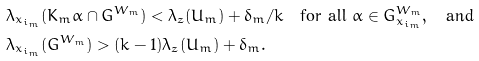<formula> <loc_0><loc_0><loc_500><loc_500>& \lambda _ { x _ { i _ { m } } } ( K _ { m } \alpha \cap G ^ { W _ { m } } ) < \lambda _ { z } ( U _ { m } ) + \delta _ { m } / k \quad \text {for all } \alpha \in G _ { x _ { i _ { m } } } ^ { W _ { m } } , \quad \text {and} \\ & \lambda _ { x _ { i _ { m } } } ( G ^ { W _ { m } } ) > ( k - 1 ) \lambda _ { z } ( U _ { m } ) + \delta _ { m } .</formula> 